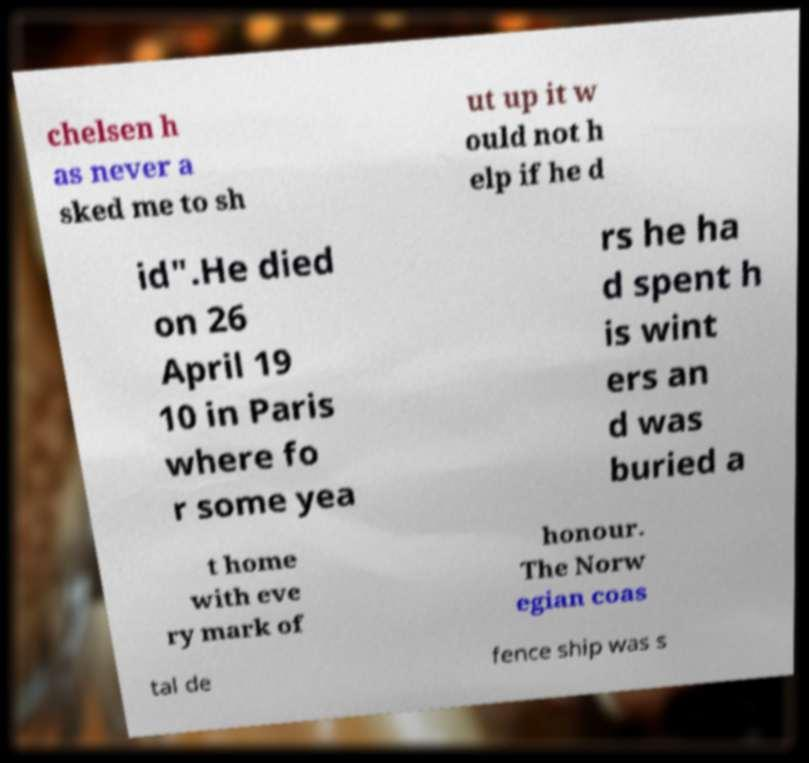Could you extract and type out the text from this image? chelsen h as never a sked me to sh ut up it w ould not h elp if he d id".He died on 26 April 19 10 in Paris where fo r some yea rs he ha d spent h is wint ers an d was buried a t home with eve ry mark of honour. The Norw egian coas tal de fence ship was s 